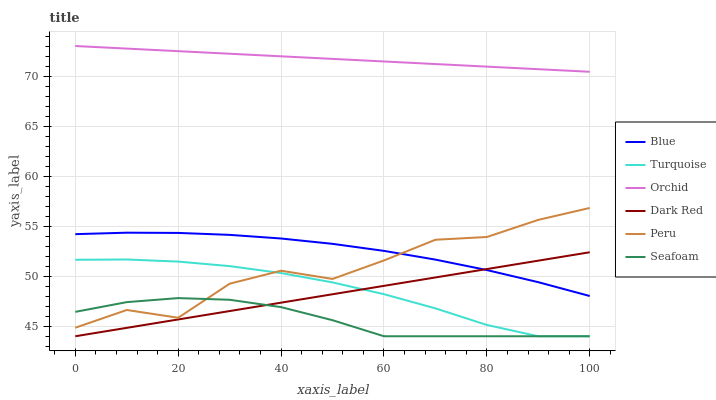Does Seafoam have the minimum area under the curve?
Answer yes or no. Yes. Does Orchid have the maximum area under the curve?
Answer yes or no. Yes. Does Turquoise have the minimum area under the curve?
Answer yes or no. No. Does Turquoise have the maximum area under the curve?
Answer yes or no. No. Is Dark Red the smoothest?
Answer yes or no. Yes. Is Peru the roughest?
Answer yes or no. Yes. Is Turquoise the smoothest?
Answer yes or no. No. Is Turquoise the roughest?
Answer yes or no. No. Does Turquoise have the lowest value?
Answer yes or no. Yes. Does Peru have the lowest value?
Answer yes or no. No. Does Orchid have the highest value?
Answer yes or no. Yes. Does Turquoise have the highest value?
Answer yes or no. No. Is Peru less than Orchid?
Answer yes or no. Yes. Is Peru greater than Dark Red?
Answer yes or no. Yes. Does Dark Red intersect Blue?
Answer yes or no. Yes. Is Dark Red less than Blue?
Answer yes or no. No. Is Dark Red greater than Blue?
Answer yes or no. No. Does Peru intersect Orchid?
Answer yes or no. No. 